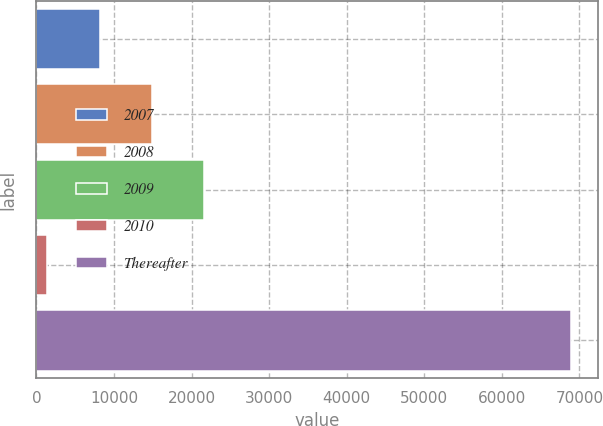<chart> <loc_0><loc_0><loc_500><loc_500><bar_chart><fcel>2007<fcel>2008<fcel>2009<fcel>2010<fcel>Thereafter<nl><fcel>8140.1<fcel>14890.2<fcel>21640.3<fcel>1390<fcel>68891<nl></chart> 